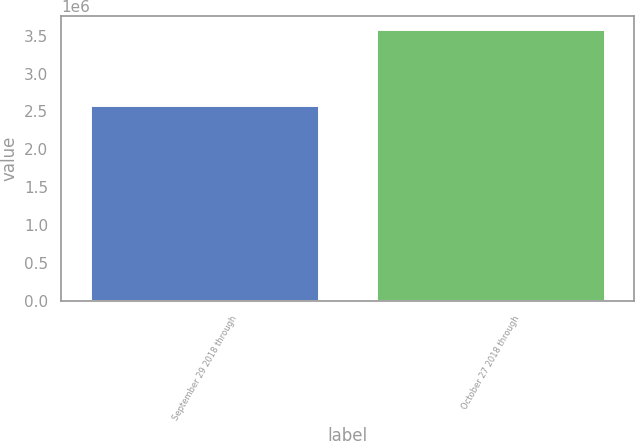Convert chart. <chart><loc_0><loc_0><loc_500><loc_500><bar_chart><fcel>September 29 2018 through<fcel>October 27 2018 through<nl><fcel>2.5848e+06<fcel>3.5842e+06<nl></chart> 